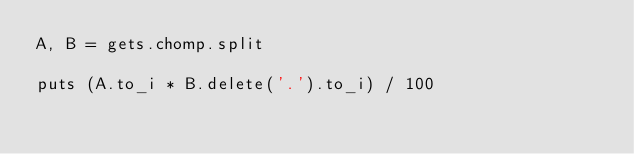Convert code to text. <code><loc_0><loc_0><loc_500><loc_500><_Ruby_>A, B = gets.chomp.split

puts (A.to_i * B.delete('.').to_i) / 100</code> 